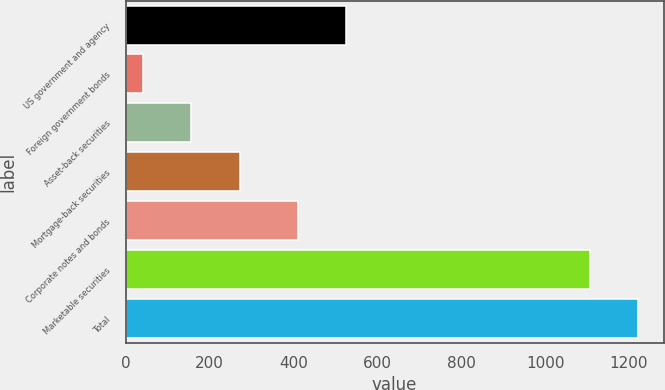<chart> <loc_0><loc_0><loc_500><loc_500><bar_chart><fcel>US government and agency<fcel>Foreign government bonds<fcel>Asset-back securities<fcel>Mortgage-back securities<fcel>Corporate notes and bonds<fcel>Marketable securities<fcel>Total<nl><fcel>526.53<fcel>41<fcel>156.43<fcel>271.86<fcel>411.1<fcel>1105.8<fcel>1221.23<nl></chart> 